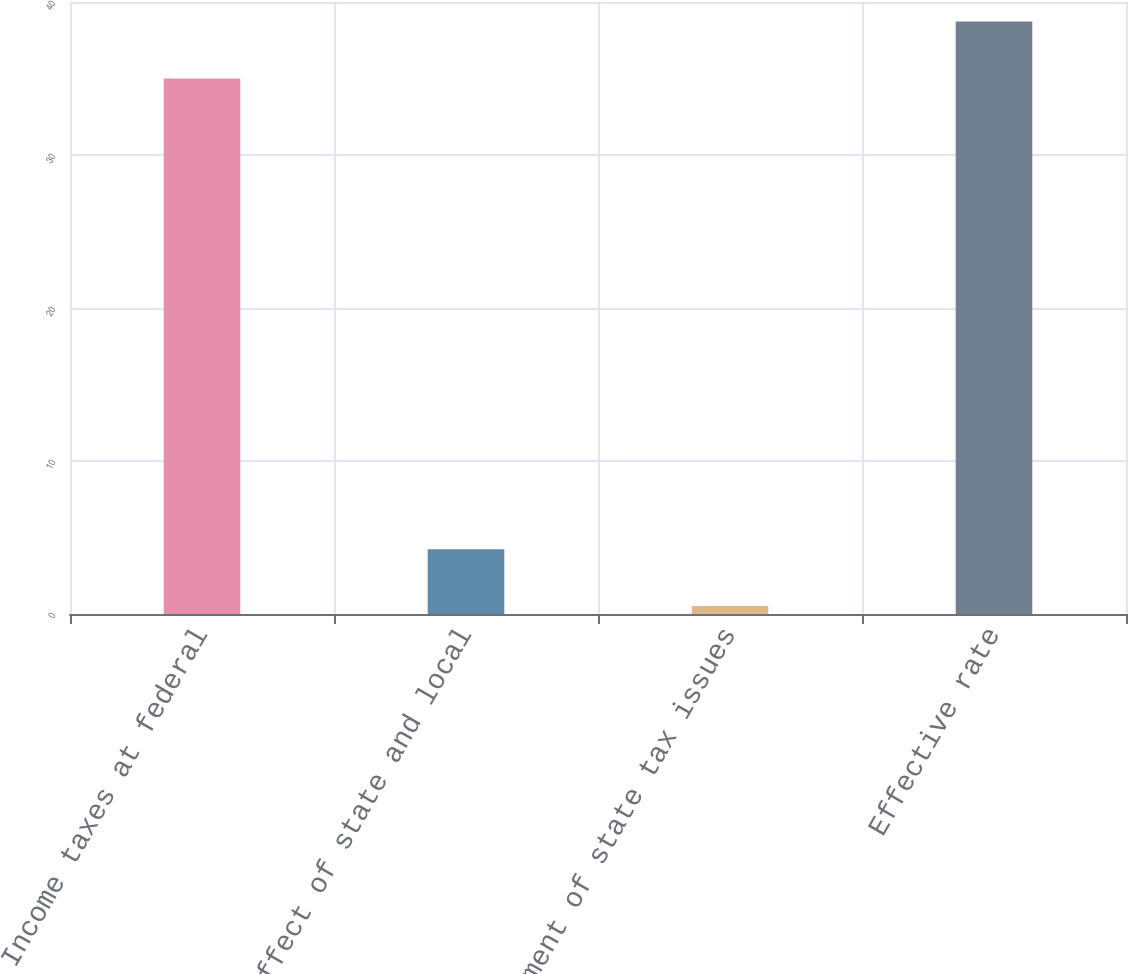Convert chart. <chart><loc_0><loc_0><loc_500><loc_500><bar_chart><fcel>Income taxes at federal<fcel>Effect of state and local<fcel>Settlement of state tax issues<fcel>Effective rate<nl><fcel>35<fcel>4.24<fcel>0.52<fcel>38.72<nl></chart> 